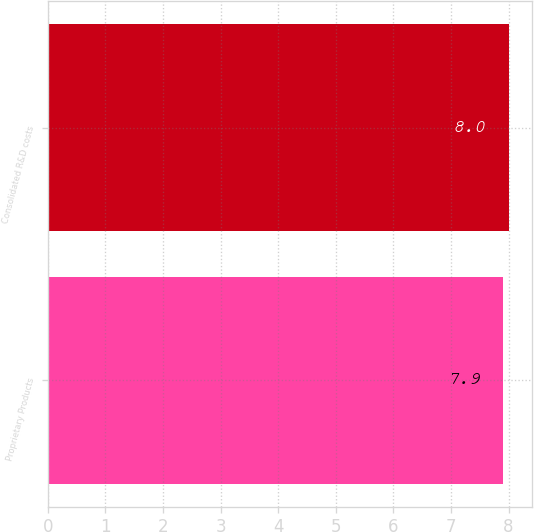Convert chart. <chart><loc_0><loc_0><loc_500><loc_500><bar_chart><fcel>Proprietary Products<fcel>Consolidated R&D costs<nl><fcel>7.9<fcel>8<nl></chart> 